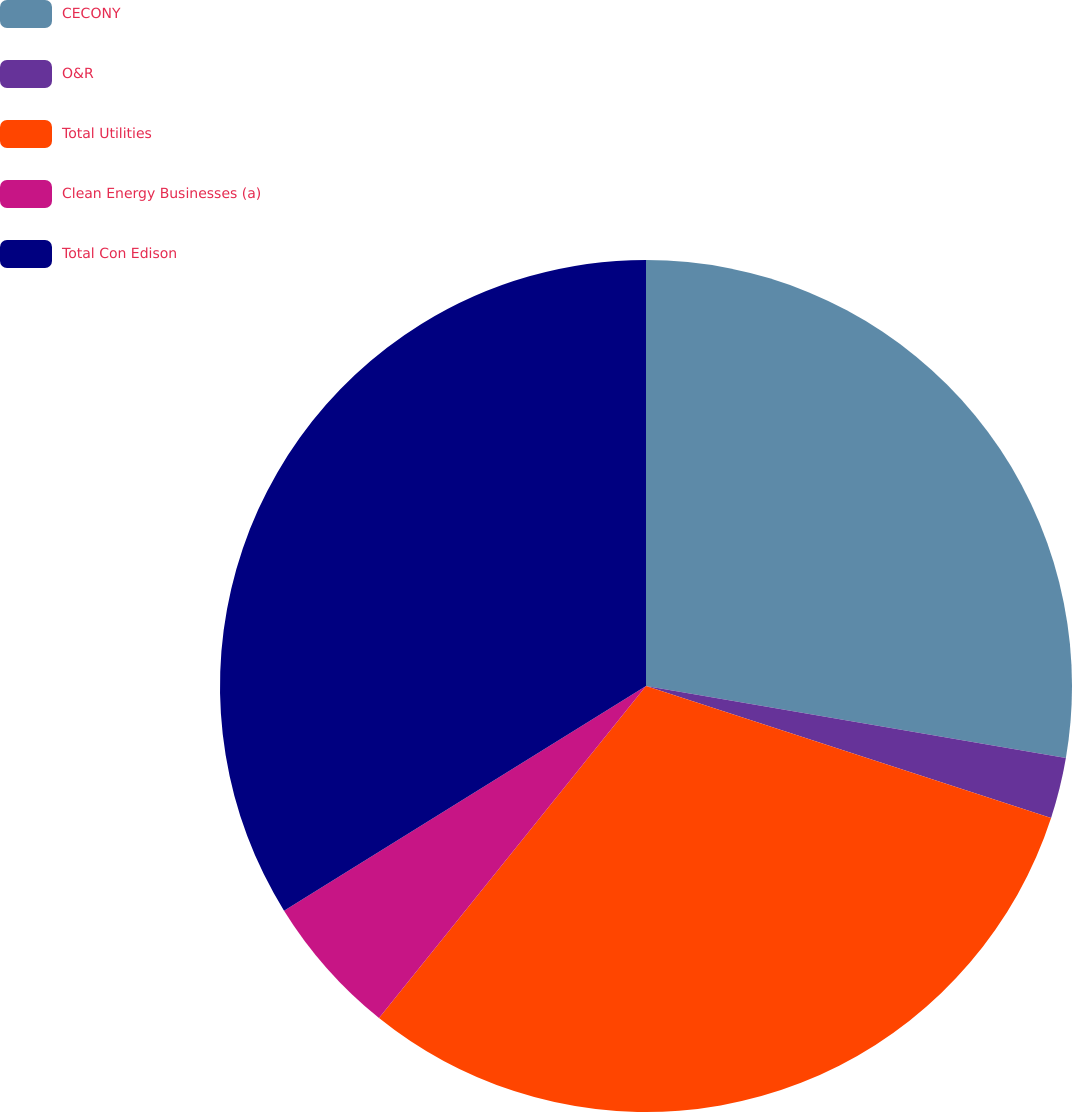Convert chart to OTSL. <chart><loc_0><loc_0><loc_500><loc_500><pie_chart><fcel>CECONY<fcel>O&R<fcel>Total Utilities<fcel>Clean Energy Businesses (a)<fcel>Total Con Edison<nl><fcel>27.7%<fcel>2.31%<fcel>30.77%<fcel>5.38%<fcel>33.84%<nl></chart> 